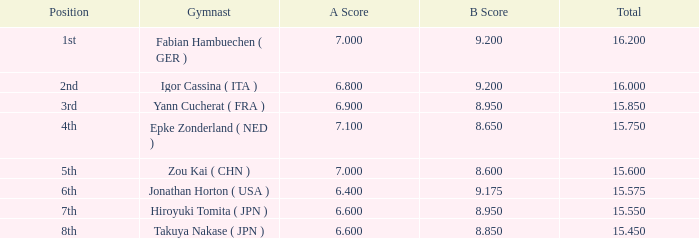65? None. Can you parse all the data within this table? {'header': ['Position', 'Gymnast', 'A Score', 'B Score', 'Total'], 'rows': [['1st', 'Fabian Hambuechen ( GER )', '7.000', '9.200', '16.200'], ['2nd', 'Igor Cassina ( ITA )', '6.800', '9.200', '16.000'], ['3rd', 'Yann Cucherat ( FRA )', '6.900', '8.950', '15.850'], ['4th', 'Epke Zonderland ( NED )', '7.100', '8.650', '15.750'], ['5th', 'Zou Kai ( CHN )', '7.000', '8.600', '15.600'], ['6th', 'Jonathan Horton ( USA )', '6.400', '9.175', '15.575'], ['7th', 'Hiroyuki Tomita ( JPN )', '6.600', '8.950', '15.550'], ['8th', 'Takuya Nakase ( JPN )', '6.600', '8.850', '15.450']]} 